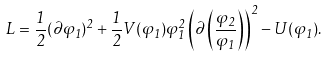<formula> <loc_0><loc_0><loc_500><loc_500>L = \frac { 1 } { 2 } ( \partial \varphi _ { 1 } ) ^ { 2 } + \frac { 1 } { 2 } V ( \varphi _ { 1 } ) \varphi _ { 1 } ^ { 2 } \left ( \partial \left ( \frac { \varphi _ { 2 } } { \varphi _ { 1 } } \right ) \right ) ^ { 2 } - U ( \varphi _ { 1 } ) .</formula> 